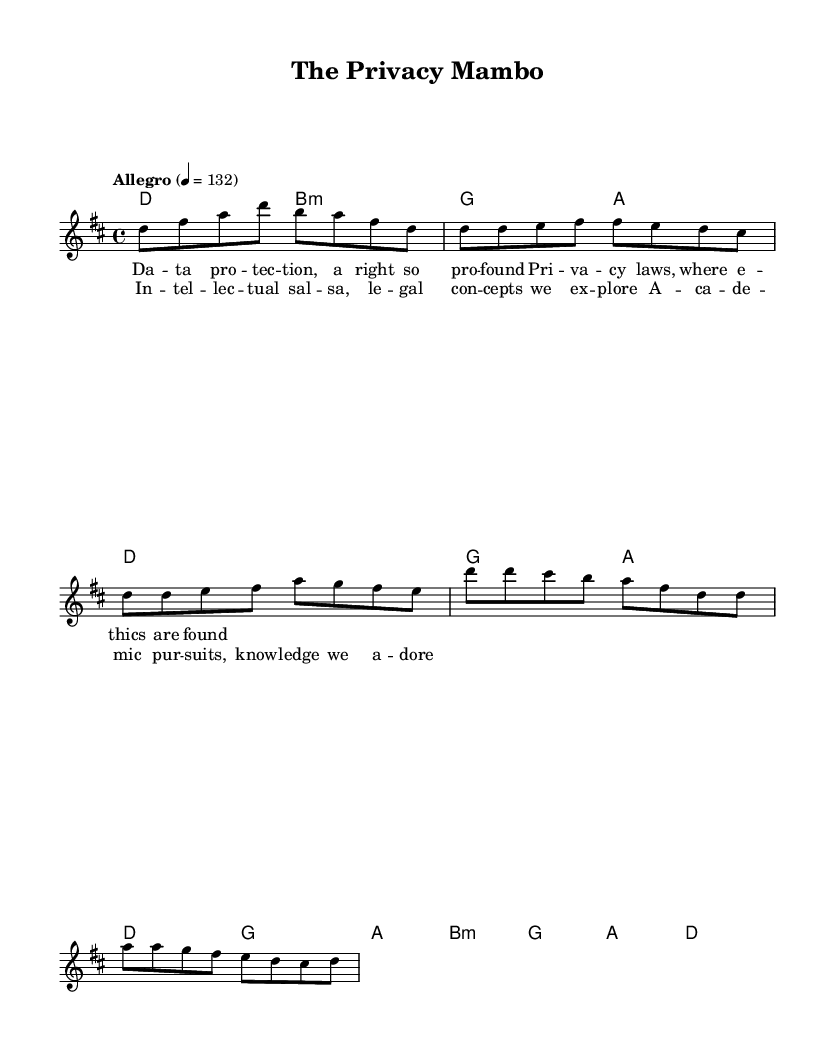What is the key signature of this music? The key signature is D major, which has two sharps (F# and C#). This can be identified at the beginning of the score, where the sharps are indicated.
Answer: D major What is the time signature of this music? The time signature is 4/4, which means there are four beats in a measure and a quarter note gets one beat. This is shown at the beginning of the score in the same area as the key signature.
Answer: 4/4 What is the tempo marking of this piece? The tempo marking is "Allegro," indicating a fast and lively pace. The number "132" denotes the beats per minute, which is indicated explicitly in the tempo directive.
Answer: Allegro How many measures are in the verse section? The verse section contains eight measures, as can be counted by the grouping of the notes and chords in that section.
Answer: 8 What are the primary themes explored in the lyrics? The themes include privacy laws, ethics, intellectual pursuits, and academic knowledge. Each lyric corresponds to the content of the music, reflecting legal concepts and academia, which can be summarized from the lyrics.
Answer: Privacy laws, ethics, academic knowledge How does the chorus relate to the verse musically? The chorus musically relates to the verse by maintaining a similar melodic structure while enhancing the thematic focus on legal and academic concepts. This can be understood through comparing the melodic lines and lyrical content.
Answer: Similar melodic structure What is the overall mood of the piece based on the tempo and lyrics? The overall mood of the piece is upbeat and lively, driven by the Allegro tempo and the energetic themes in the lyrics about legal concepts and academia, which combine to create a positive, engaging atmosphere.
Answer: Upbeat 